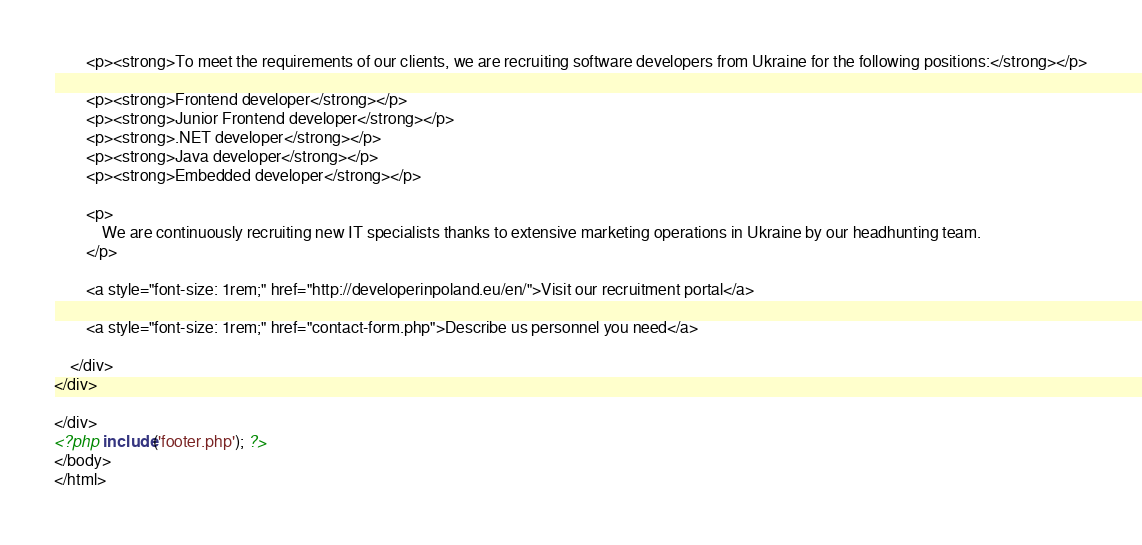<code> <loc_0><loc_0><loc_500><loc_500><_PHP_>        <p><strong>To meet the requirements of our clients, we are recruiting software developers from Ukraine for the following positions:</strong></p>

        <p><strong>Frontend developer</strong></p>
        <p><strong>Junior Frontend developer</strong></p>
        <p><strong>.NET developer</strong></p>
        <p><strong>Java developer</strong></p>
        <p><strong>Embedded developer</strong></p>

        <p>
            We are continuously recruiting new IT specialists thanks to extensive marketing operations in Ukraine by our headhunting team.
        </p>

        <a style="font-size: 1rem;" href="http://developerinpoland.eu/en/">Visit our recruitment portal</a>

        <a style="font-size: 1rem;" href="contact-form.php">Describe us personnel you need</a>

    </div>
</div>

</div>
<?php include('footer.php'); ?>
</body>
</html></code> 